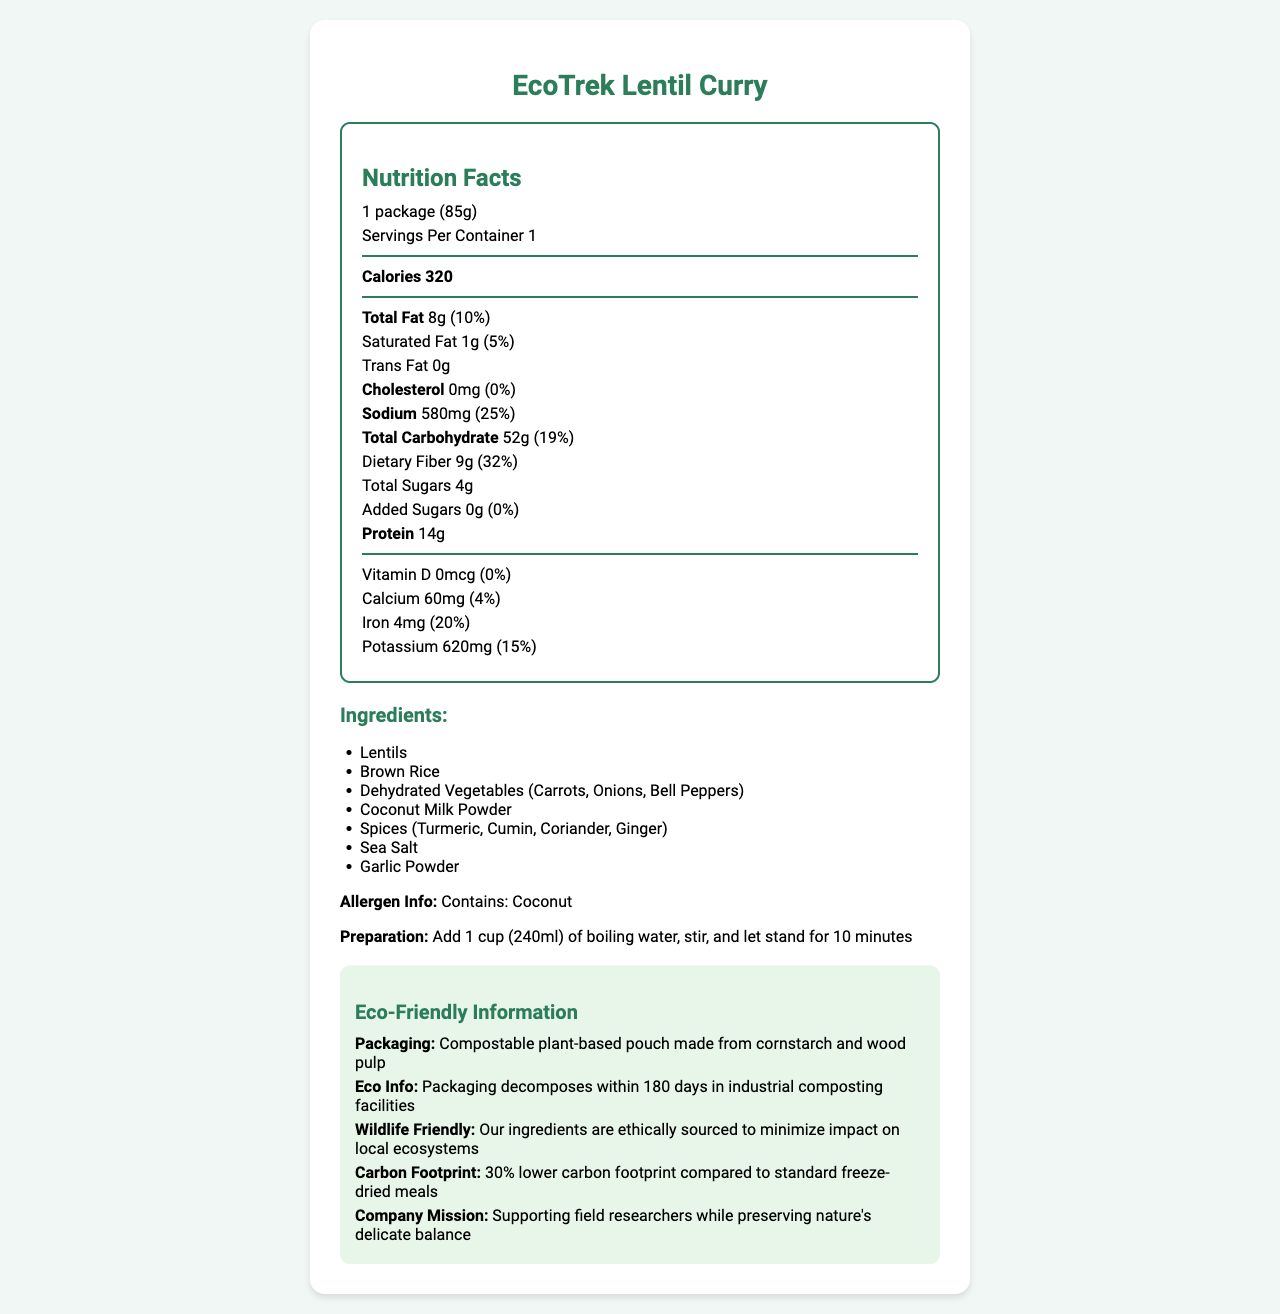what is the product name? The product name is listed at the top of the document.
Answer: EcoTrek Lentil Curry what is the serving size? The serving size is specified as "1 package (85g)" in the Nutrition Facts section.
Answer: 1 package (85g) how many calories are in one serving? The number of calories per serving is specified as 320 in the Nutrition Facts section.
Answer: 320 list three main ingredients of the product. The ingredients list includes Lentils, Brown Rice, and Dehydrated Vegetables (Carrots, Onions, Bell Peppers) as the first three ingredients.
Answer: Lentils, Brown Rice, Dehydrated Vegetables (Carrots, Onions, Bell Peppers) what percentage of daily iron does this product provide? The Nutrition Facts state that the product provides 20% of the daily value for iron.
Answer: 20% what is the total fat content per serving? The total fat content per serving is listed as 8g in the Nutrition Facts section.
Answer: 8g how is the product prepared? The preparation instructions are to add 1 cup (240ml) of boiling water, stir, and let stand for 10 minutes.
Answer: Add 1 cup (240ml) of boiling water, stir, and let stand for 10 minutes how many grams of dietary fiber does one serving contain? The Nutrition Facts indicate that one serving contains 9g of dietary fiber.
Answer: 9g does the product contain any cholesterol? The Nutrition Facts list the cholesterol amount as 0mg, indicating the product contains no cholesterol.
Answer: No which of the following best describes the packaging material? i) Plastic ii) Compostable plant-based pouch iii) Glass container The document states that the packaging is a "Compostable plant-based pouch made from cornstarch and wood pulp".
Answer: ii) Compostable plant-based pouch how much sodium is in one serving? a) 200mg b) 580mg c) 800mg d) 1000mg The document specifies that one serving contains 580mg of sodium.
Answer: b) 580mg is the packaging of the product wildlife friendly? The eco-friendly information section mentions that the ingredients are ethically sourced to minimize impact on local ecosystems, which indicates that the packaging is wildlife friendly.
Answer: Yes summarize the main idea of this document. The document gives a comprehensive overview of the nutritional facts, preparation method, ingredients, allergen information, eco-friendly packaging, and the company's mission to support field researchers while preserving nature.
Answer: The document provides detailed nutritional information, ingredients, preparation instructions, and eco-friendly credentials for EcoTrek Lentil Curry, a dehydrated vegetarian meal packaged in biodegradable material, and highlights its environmental benefits. how long does it take for the packaging to decompose in industrial composting facilities? The eco-friendly information section states that the packaging decomposes within 180 days in industrial composting facilities.
Answer: 180 days what is the protein content per serving? The protein content per serving is listed as 14g in the Nutrition Facts section.
Answer: 14g what is the daily value percentage of vitamin D in the product? The Nutrition Facts indicate that the daily value percentage of vitamin D in the product is 0%.
Answer: 0% what is the carbon footprint reduction of this product compared to standard freeze-dried meals? The eco-friendly information specifies that the carbon footprint of this product is 30% lower compared to standard freeze-dried meals.
Answer: 30% what type of packaging is used for the product? The document mentions that the packaging is a compostable plant-based pouch made from cornstarch and wood pulp.
Answer: Compostable plant-based pouch made from cornstarch and wood pulp what is the total carbohydrate content per serving? The document lists the total carbohydrate content per serving as 52g.
Answer: 52g what is the primary allergen in the product? The allergen information states that the product contains coconut.
Answer: Coconut who is the target audience for this product? The company mission is to support field researchers while preserving nature's delicate balance, indicating that field researchers are the target audience.
Answer: Field researchers what is the potassium content in one serving? a) 400mg b) 520mg c) 620mg The Nutrition Facts list the potassium content as 620mg.
Answer: c) 620mg what is the purpose of the "Summary" section? The document provided does not include a labeled "Summary" section, so the purpose cannot be determined.
Answer: Not enough information 